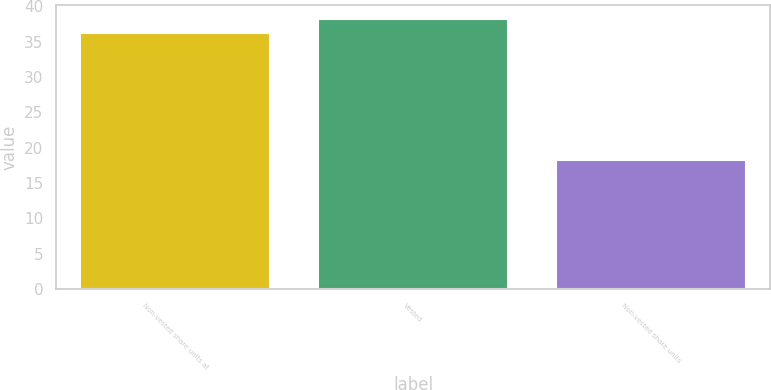Convert chart. <chart><loc_0><loc_0><loc_500><loc_500><bar_chart><fcel>Non-vested share units at<fcel>Vested<fcel>Non-vested share units<nl><fcel>36.24<fcel>38.26<fcel>18.26<nl></chart> 